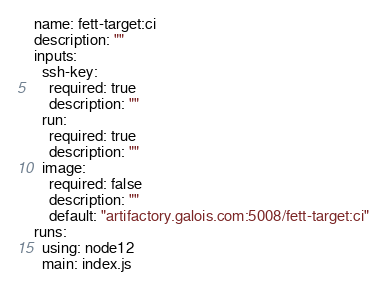Convert code to text. <code><loc_0><loc_0><loc_500><loc_500><_YAML_>name: fett-target:ci
description: ""
inputs:
  ssh-key:
    required: true
    description: ""
  run:
    required: true
    description: ""
  image:
    required: false
    description: ""
    default: "artifactory.galois.com:5008/fett-target:ci"
runs:
  using: node12
  main: index.js
</code> 